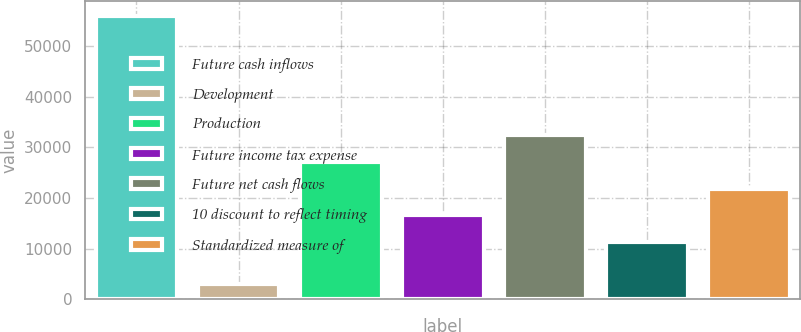<chart> <loc_0><loc_0><loc_500><loc_500><bar_chart><fcel>Future cash inflows<fcel>Development<fcel>Production<fcel>Future income tax expense<fcel>Future net cash flows<fcel>10 discount to reflect timing<fcel>Standardized measure of<nl><fcel>55954<fcel>2954<fcel>27158<fcel>16558<fcel>32458<fcel>11258<fcel>21858<nl></chart> 